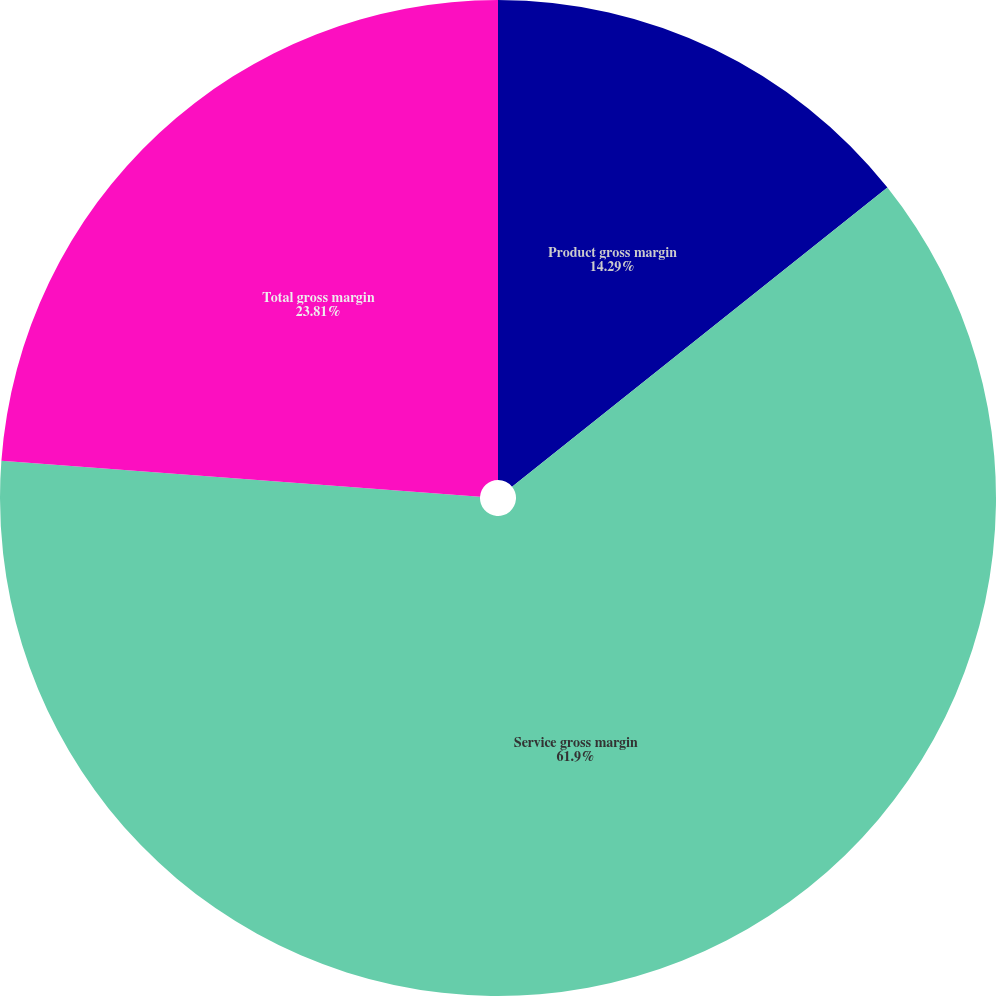Convert chart. <chart><loc_0><loc_0><loc_500><loc_500><pie_chart><fcel>Product gross margin<fcel>Service gross margin<fcel>Total gross margin<nl><fcel>14.29%<fcel>61.9%<fcel>23.81%<nl></chart> 